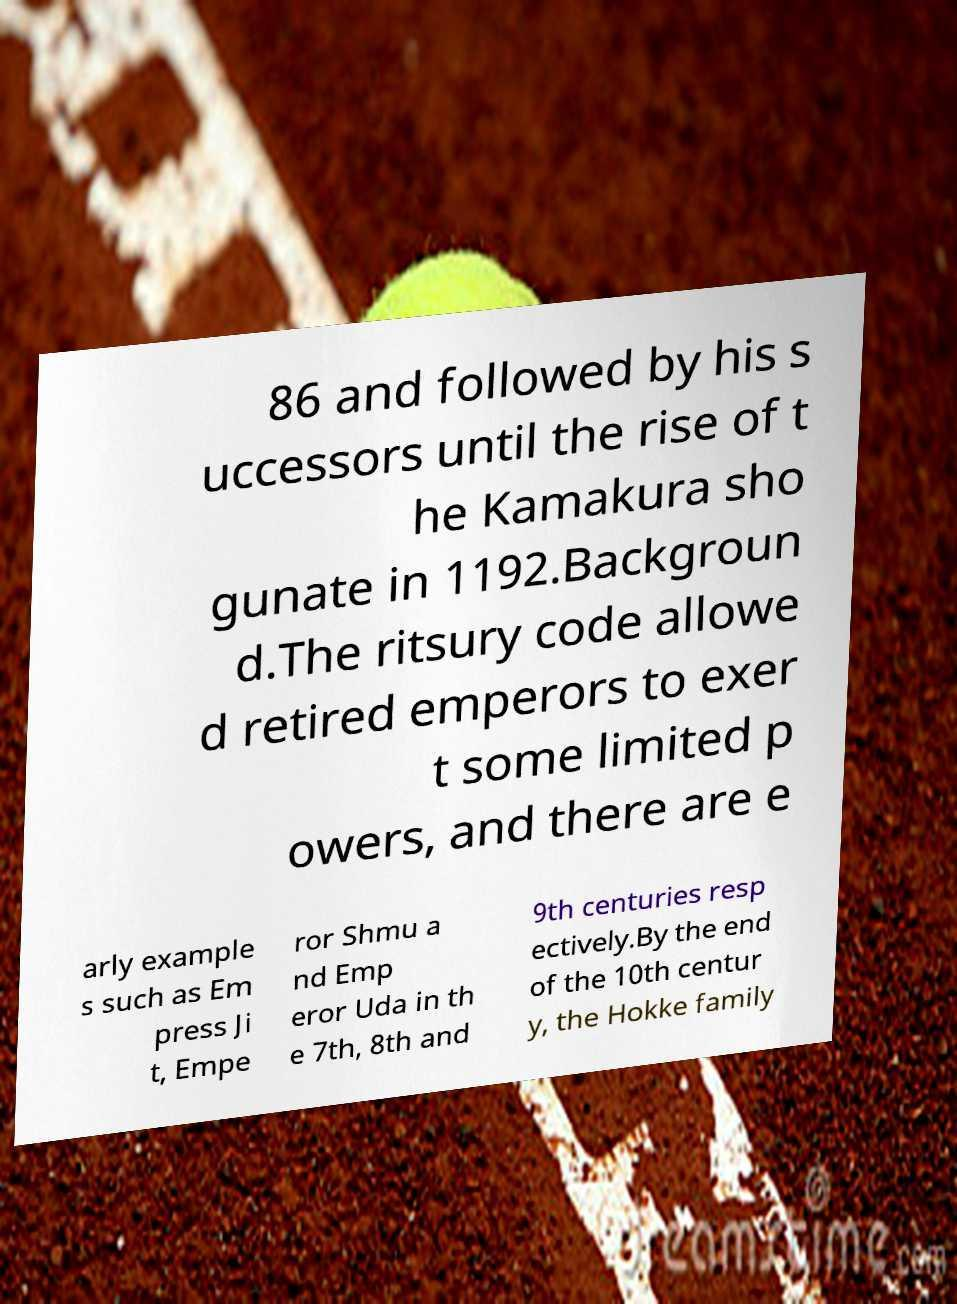There's text embedded in this image that I need extracted. Can you transcribe it verbatim? 86 and followed by his s uccessors until the rise of t he Kamakura sho gunate in 1192.Backgroun d.The ritsury code allowe d retired emperors to exer t some limited p owers, and there are e arly example s such as Em press Ji t, Empe ror Shmu a nd Emp eror Uda in th e 7th, 8th and 9th centuries resp ectively.By the end of the 10th centur y, the Hokke family 